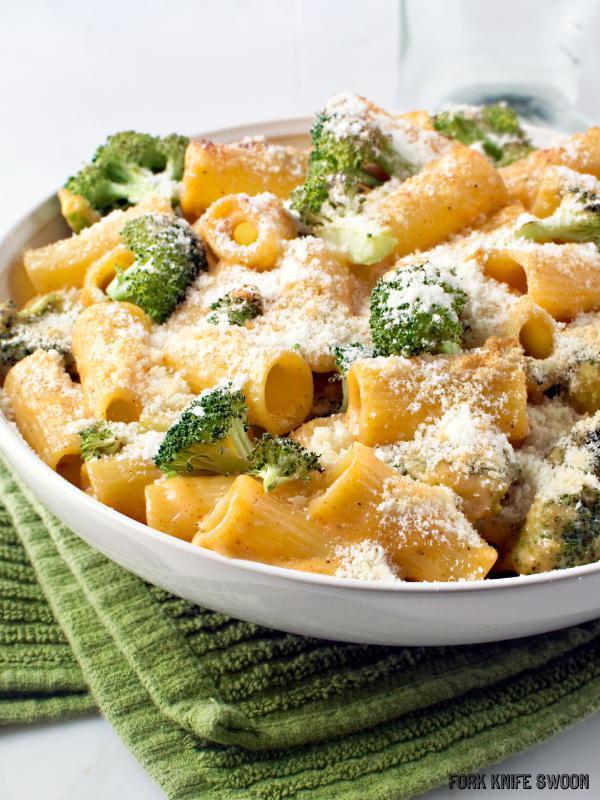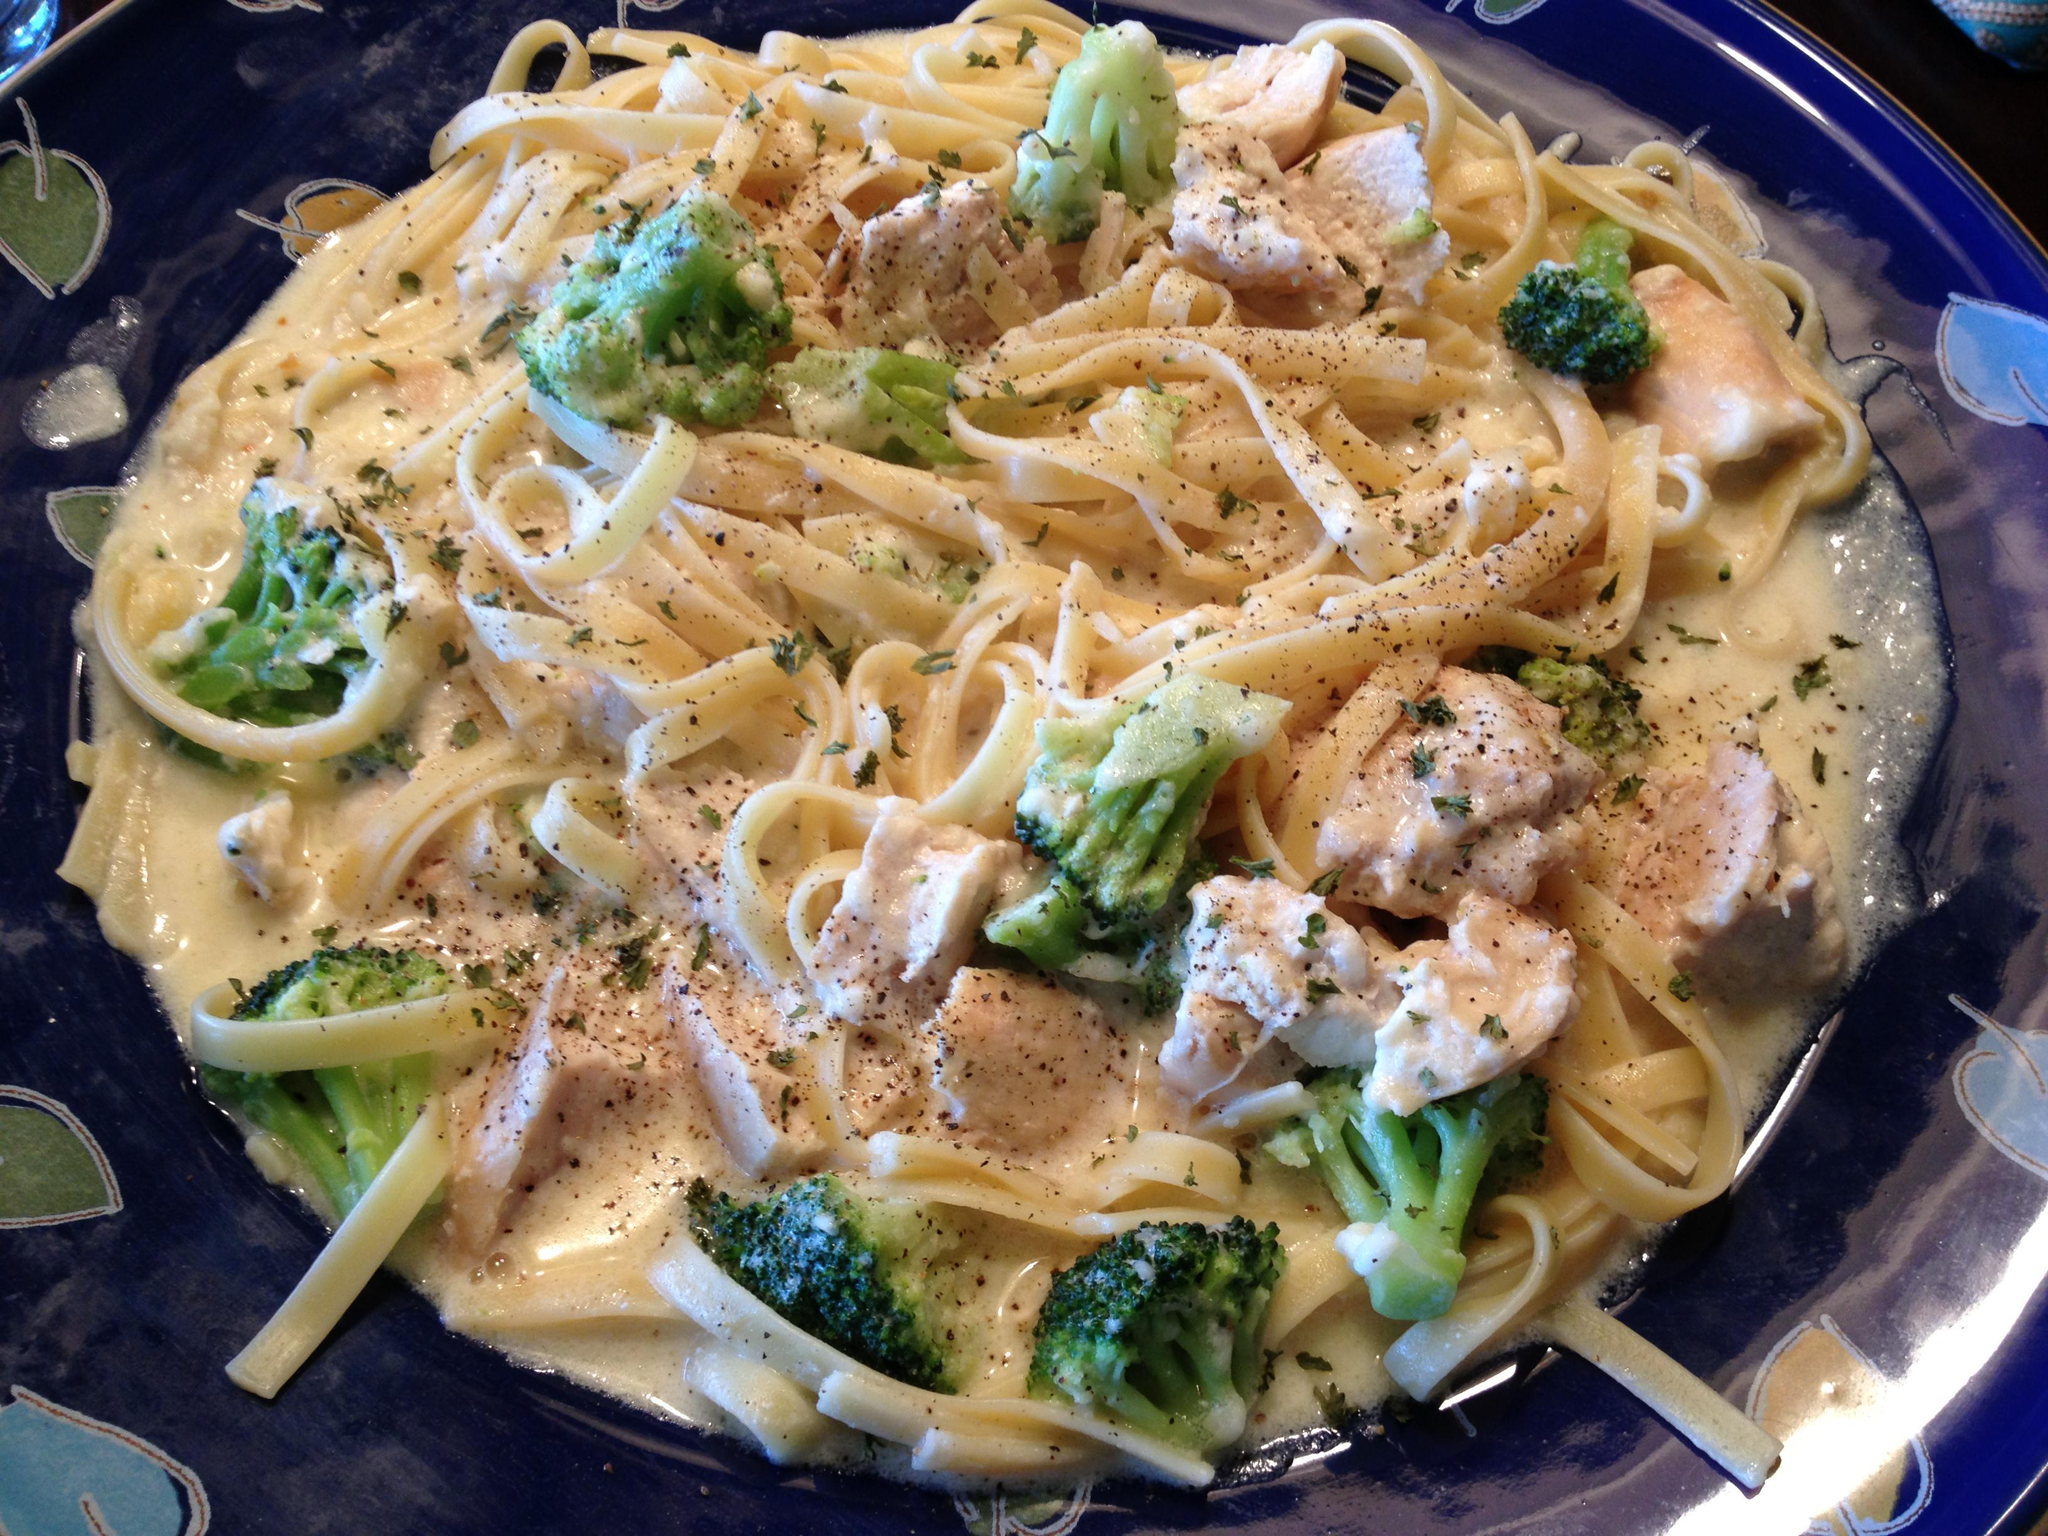The first image is the image on the left, the second image is the image on the right. Assess this claim about the two images: "A fork is resting on a plate of pasta in one image.". Correct or not? Answer yes or no. No. 